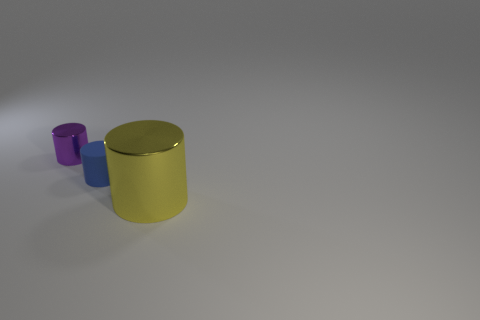Is there any other thing that is the same size as the yellow metal cylinder?
Provide a short and direct response. No. What is the shape of the small thing that is right of the metallic cylinder that is on the left side of the yellow metal cylinder?
Your answer should be compact. Cylinder. What is the color of the matte object that is the same shape as the purple shiny object?
Your answer should be compact. Blue. The thing that is in front of the purple thing and behind the big yellow shiny thing has what shape?
Keep it short and to the point. Cylinder. Are there fewer rubber objects than green shiny cylinders?
Provide a succinct answer. No. Are any green shiny cylinders visible?
Offer a very short reply. No. What number of other objects are the same size as the rubber cylinder?
Offer a very short reply. 1. Do the large thing and the thing that is on the left side of the tiny blue matte cylinder have the same material?
Provide a succinct answer. Yes. Are there an equal number of large yellow shiny things that are right of the big metal cylinder and tiny blue matte cylinders that are in front of the tiny blue cylinder?
Offer a very short reply. Yes. What material is the blue thing?
Keep it short and to the point. Rubber. 